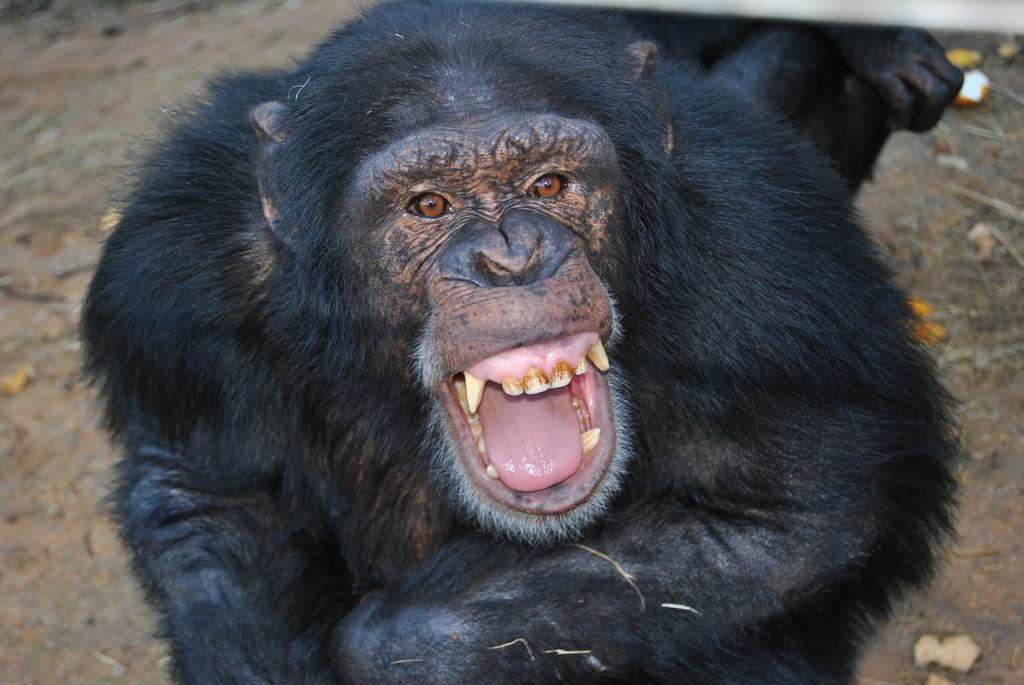What type of animal is in the image? There is a chimpanzee in the image. What color is the chimpanzee? The chimpanzee is black in color. What can be seen on the ground in the image? Dried leaves are lying on the ground in the image. What type of rice is being grown in the image? There is no rice present in the image; it features a chimpanzee and dried leaves on the ground. Can you see any clover plants in the image? There is no mention of clover plants in the image; it only features a chimpanzee, dried leaves, and the ground. 